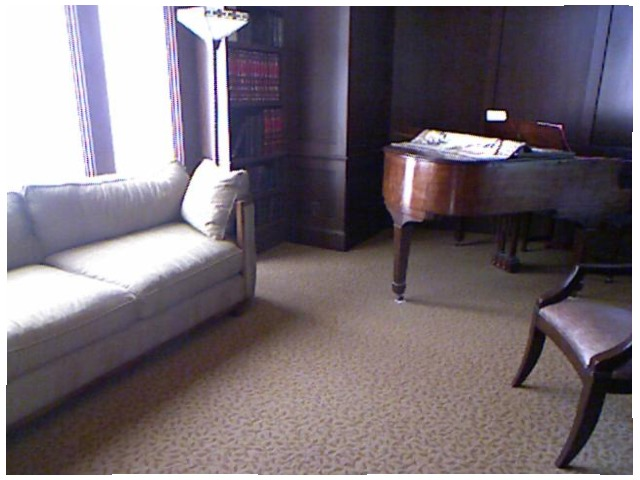<image>
Is there a couch on the floor? Yes. Looking at the image, I can see the couch is positioned on top of the floor, with the floor providing support. Where is the table in relation to the sofa? Is it next to the sofa? Yes. The table is positioned adjacent to the sofa, located nearby in the same general area. Is there a lamp above the pillow? Yes. The lamp is positioned above the pillow in the vertical space, higher up in the scene. 